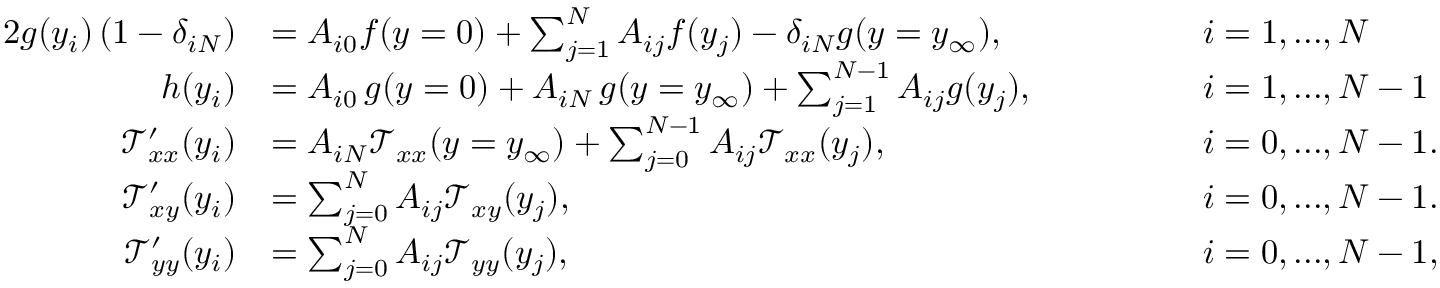Convert formula to latex. <formula><loc_0><loc_0><loc_500><loc_500>\begin{array} { r l r l } { { 2 } g ( y _ { i } ) \left ( 1 - \delta _ { i N } \right ) } & { = A _ { i 0 } f ( y = 0 ) + \sum _ { j = 1 } ^ { N } A _ { i j } f ( y _ { j } ) - \delta _ { i N } g ( y = y _ { \infty } ) , \quad } & & { i = 1 , \dots , N } \\ { h ( y _ { i } ) } & { = A _ { i 0 } \, g ( y = 0 ) + A _ { i N } \, g ( y = y _ { \infty } ) + \sum _ { j = 1 } ^ { N - 1 } A _ { i j } g ( y _ { j } ) , \quad } & & { i = 1 , \dots , N - 1 } \\ { \mathcal { T } _ { x x } ^ { \prime } ( y _ { i } ) } & { = A _ { i N } \mathcal { T } _ { x x } ( y = y _ { \infty } ) + \sum _ { j = 0 } ^ { N - 1 } A _ { i j } \mathcal { T } _ { x x } ( y _ { j } ) , \quad } & & { i = 0 , \dots , N - 1 . } \\ { \mathcal { T } _ { x y } ^ { \prime } ( y _ { i } ) } & { = \sum _ { j = 0 } ^ { N } A _ { i j } \mathcal { T } _ { x y } ( y _ { j } ) , \quad } & & { i = 0 , \dots , N - 1 . } \\ { \mathcal { T } _ { y y } ^ { \prime } ( y _ { i } ) } & { = \sum _ { j = 0 } ^ { N } A _ { i j } \mathcal { T } _ { y y } ( y _ { j } ) , \quad } & & { i = 0 , \dots , N - 1 , } \end{array}</formula> 